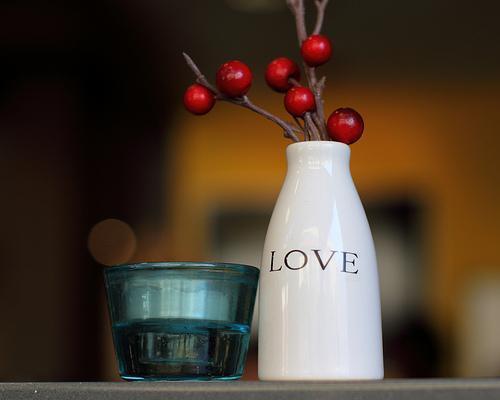How many jugs are visible?
Give a very brief answer. 1. How many containers have the word love on them?
Give a very brief answer. 1. 